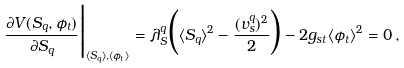<formula> <loc_0><loc_0><loc_500><loc_500>\frac { \partial V ( S _ { q } , \phi _ { t } ) } { \partial S _ { q } } \Big | _ { \langle S _ { q } \rangle , \langle \phi _ { t } \rangle } = \lambda _ { S } ^ { q } \Big ( \langle S _ { q } \rangle ^ { 2 } - \frac { ( v _ { s } ^ { q } ) ^ { 2 } } { 2 } \Big ) - 2 g _ { s t } \langle \phi _ { t } \rangle ^ { 2 } = 0 \, ,</formula> 